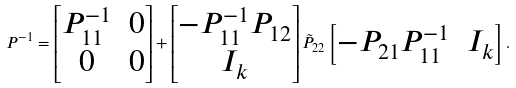Convert formula to latex. <formula><loc_0><loc_0><loc_500><loc_500>P ^ { - 1 } = \begin{bmatrix} P _ { 1 1 } ^ { - 1 } & 0 \\ 0 & 0 \end{bmatrix} + \begin{bmatrix} - P _ { 1 1 } ^ { - 1 } P _ { 1 2 } \\ I _ { k } \end{bmatrix} \tilde { P } _ { 2 2 } \begin{bmatrix} - P _ { 2 1 } P _ { 1 1 } ^ { - 1 } & I _ { k } \end{bmatrix} .</formula> 